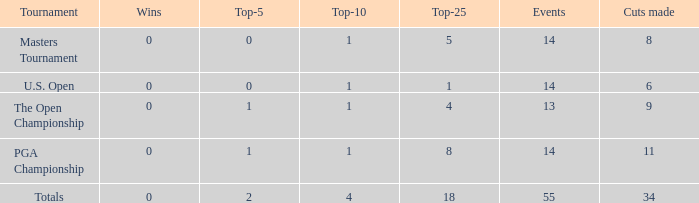What is the average top-5 when the cuts made is more than 34? None. 